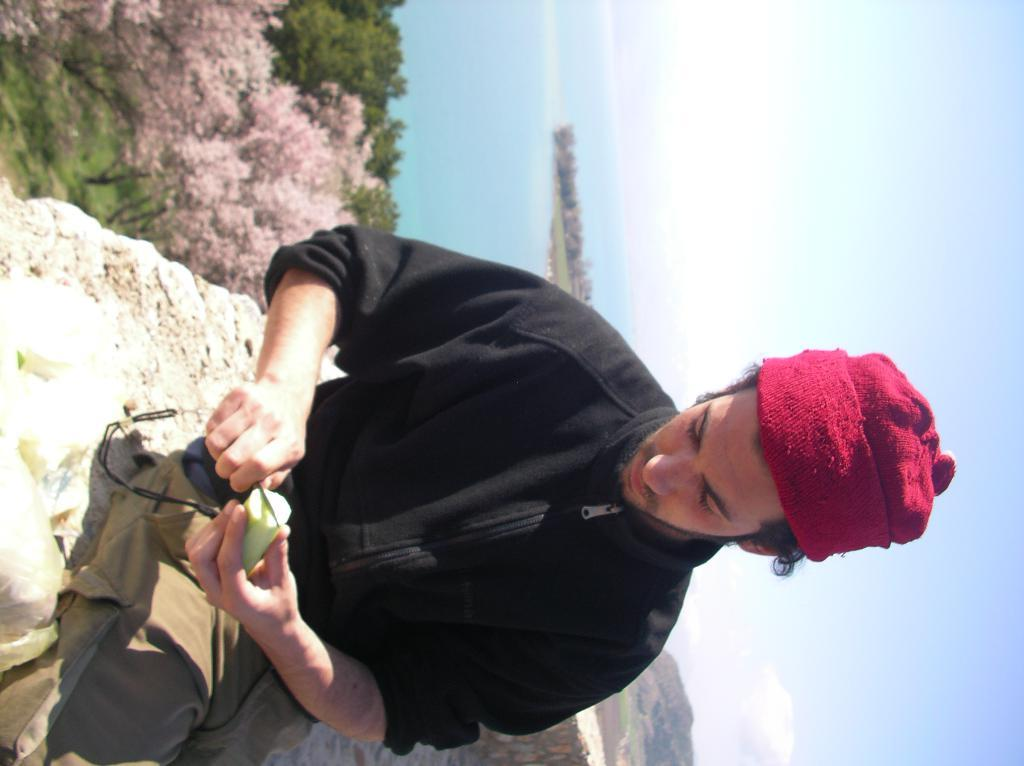Who is present in the image? There is a man in the image. What is the man wearing? The man is wearing a black jacket. What is the man doing in the image? The man is sitting and cutting a cucumber. What can be seen in the background of the image? There are hills, trees, and sky visible in the background of the image. What is the condition of the sky in the image? The sky has clouds in it. What type of sweater is the man wearing in the image? The man is not wearing a sweater in the image; he is wearing a black jacket. What time of day is it in the image? The time of day cannot be determined from the image alone. 